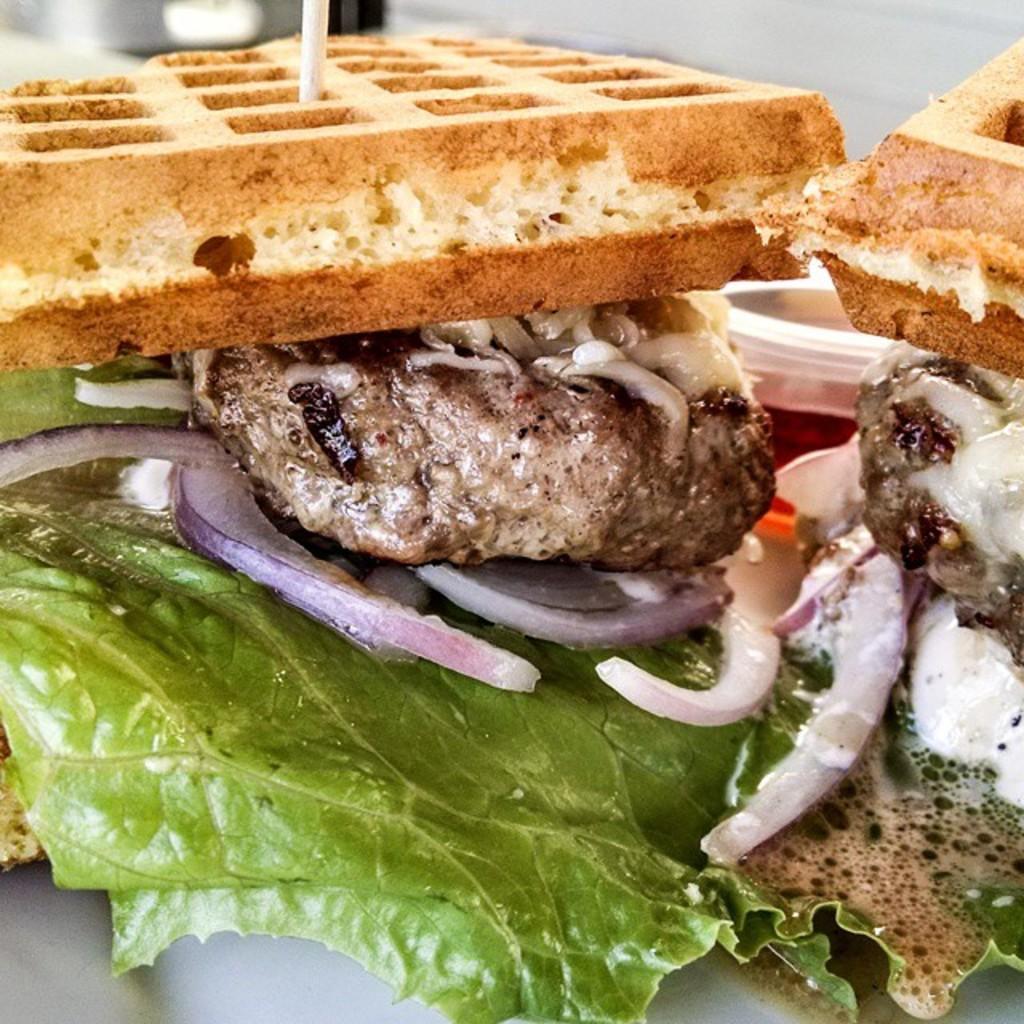How would you summarize this image in a sentence or two? In the center of the image we can see one plastic box and some food items, in which we can see onion slices, leafy vegetables, breads etc. 